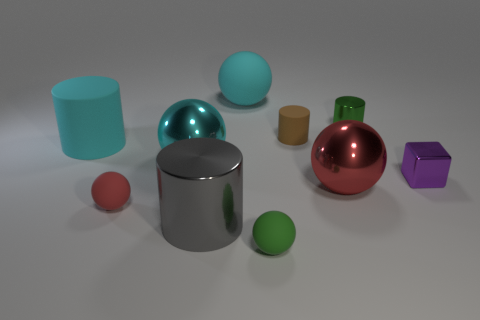Are there any cylinders of the same size as the red matte object?
Keep it short and to the point. Yes. Are the purple object and the big gray object made of the same material?
Your response must be concise. Yes. How many things are tiny green shiny cylinders or tiny rubber things?
Your answer should be very brief. 4. The red metal thing has what size?
Offer a terse response. Large. Are there fewer small matte balls than large cyan matte spheres?
Give a very brief answer. No. How many tiny things are the same color as the big metal cylinder?
Provide a short and direct response. 0. Do the rubber sphere behind the big cyan cylinder and the large rubber cylinder have the same color?
Your response must be concise. Yes. The rubber thing that is to the left of the small red object has what shape?
Provide a succinct answer. Cylinder. Are there any small matte spheres behind the cyan ball that is in front of the small green metallic cylinder?
Offer a terse response. No. What number of gray cylinders have the same material as the tiny brown object?
Your answer should be very brief. 0. 